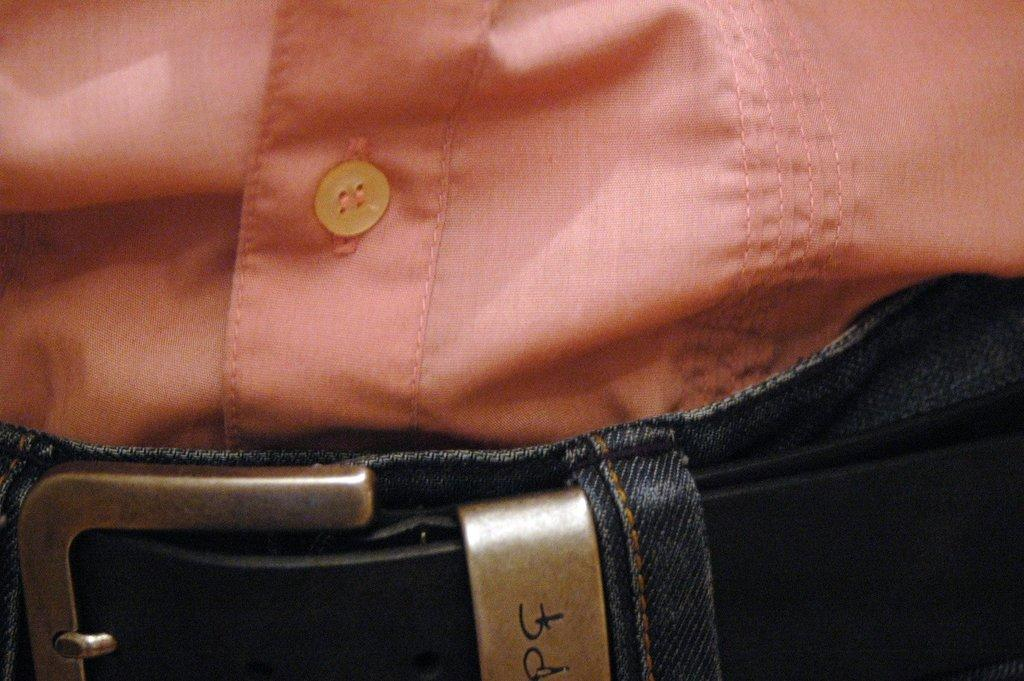What type of clothing item is in the image? There is a shirt in the image. How is the shirt positioned in relation to the trouser? The shirt is partially tucked into the trouser. What accessory is visible in the image? There is a belt visible in the image. What color is the shirt? The shirt is orange in color. What type of fastener is present on the shirt? The shirt has a button. Can you tell me how many teeth the shirt has in the image? There are no teeth present in the image, as it features a shirt and not a living organism. 